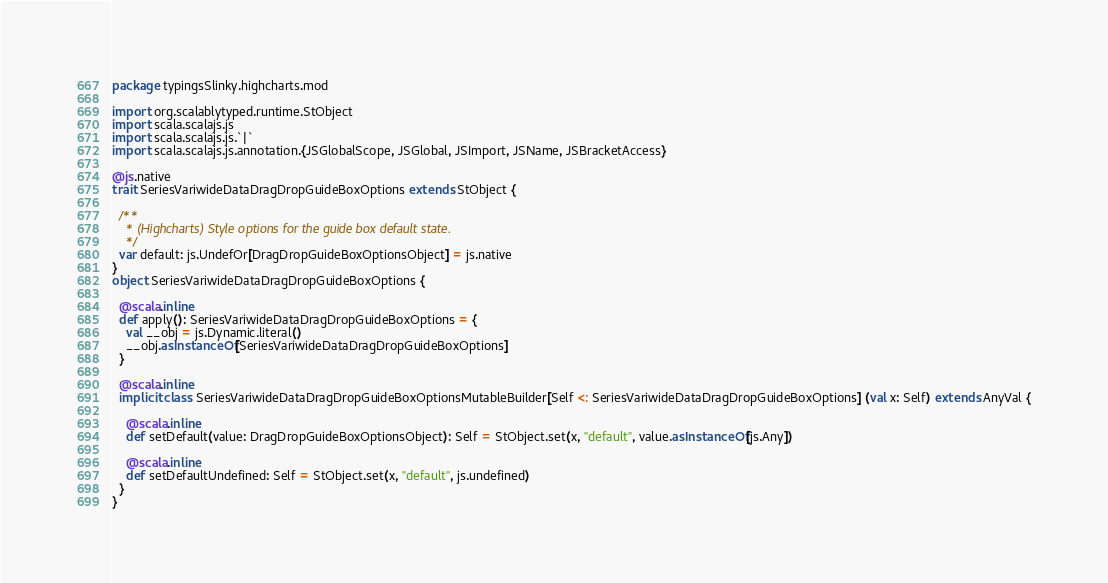Convert code to text. <code><loc_0><loc_0><loc_500><loc_500><_Scala_>package typingsSlinky.highcharts.mod

import org.scalablytyped.runtime.StObject
import scala.scalajs.js
import scala.scalajs.js.`|`
import scala.scalajs.js.annotation.{JSGlobalScope, JSGlobal, JSImport, JSName, JSBracketAccess}

@js.native
trait SeriesVariwideDataDragDropGuideBoxOptions extends StObject {
  
  /**
    * (Highcharts) Style options for the guide box default state.
    */
  var default: js.UndefOr[DragDropGuideBoxOptionsObject] = js.native
}
object SeriesVariwideDataDragDropGuideBoxOptions {
  
  @scala.inline
  def apply(): SeriesVariwideDataDragDropGuideBoxOptions = {
    val __obj = js.Dynamic.literal()
    __obj.asInstanceOf[SeriesVariwideDataDragDropGuideBoxOptions]
  }
  
  @scala.inline
  implicit class SeriesVariwideDataDragDropGuideBoxOptionsMutableBuilder[Self <: SeriesVariwideDataDragDropGuideBoxOptions] (val x: Self) extends AnyVal {
    
    @scala.inline
    def setDefault(value: DragDropGuideBoxOptionsObject): Self = StObject.set(x, "default", value.asInstanceOf[js.Any])
    
    @scala.inline
    def setDefaultUndefined: Self = StObject.set(x, "default", js.undefined)
  }
}
</code> 